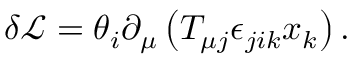<formula> <loc_0><loc_0><loc_500><loc_500>\delta \mathcal { L } = \theta _ { i } \partial _ { \mu } \left ( T _ { \mu j } \epsilon _ { j i k } x _ { k } \right ) .</formula> 